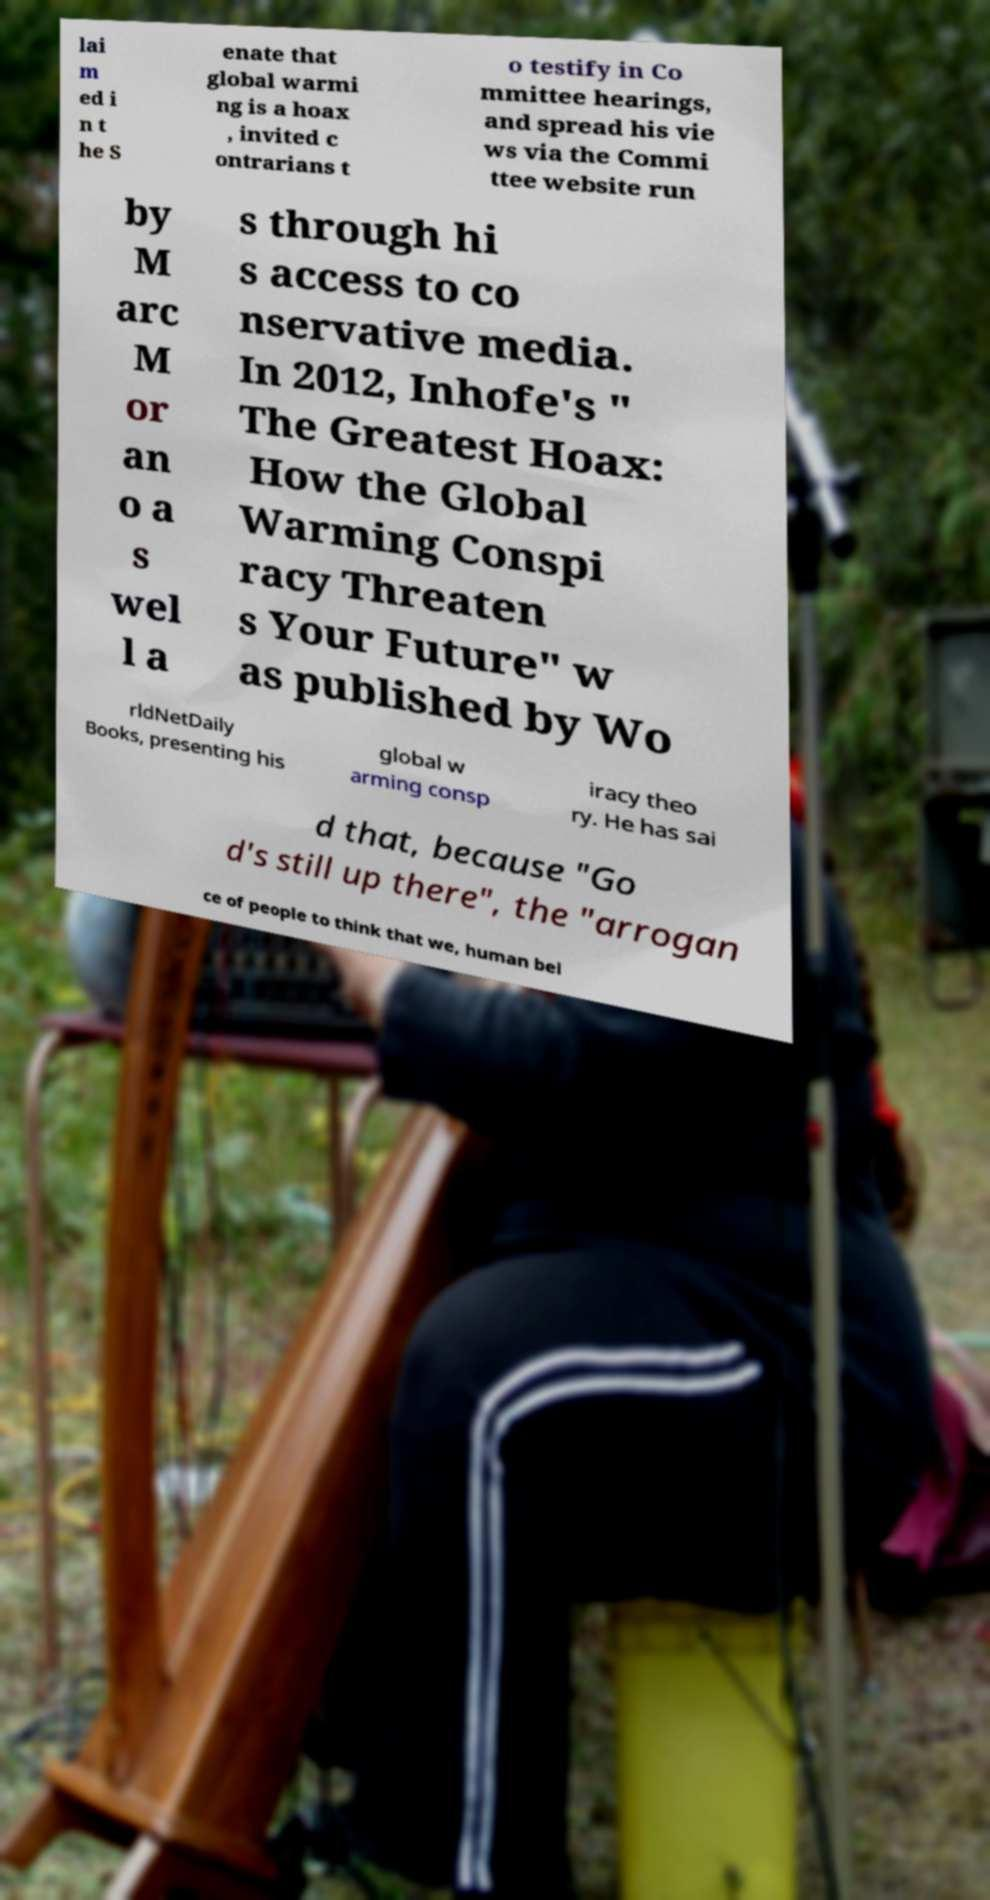Please read and relay the text visible in this image. What does it say? lai m ed i n t he S enate that global warmi ng is a hoax , invited c ontrarians t o testify in Co mmittee hearings, and spread his vie ws via the Commi ttee website run by M arc M or an o a s wel l a s through hi s access to co nservative media. In 2012, Inhofe's " The Greatest Hoax: How the Global Warming Conspi racy Threaten s Your Future" w as published by Wo rldNetDaily Books, presenting his global w arming consp iracy theo ry. He has sai d that, because "Go d's still up there", the "arrogan ce of people to think that we, human bei 